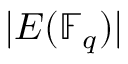<formula> <loc_0><loc_0><loc_500><loc_500>| E ( \mathbb { F } _ { q } ) |</formula> 